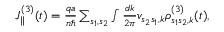<formula> <loc_0><loc_0><loc_500><loc_500>\begin{array} { r } { J _ { \| } ^ { ( 3 ) } ( t ) = \frac { q a } { n } \sum _ { s _ { 1 } , s _ { 2 } } \int \frac { d k } { 2 \pi } v _ { s _ { 2 } s _ { 1 } , k } \rho _ { s _ { 1 } s _ { 2 } , k } ^ { ( 3 ) } ( t ) , } \end{array}</formula> 